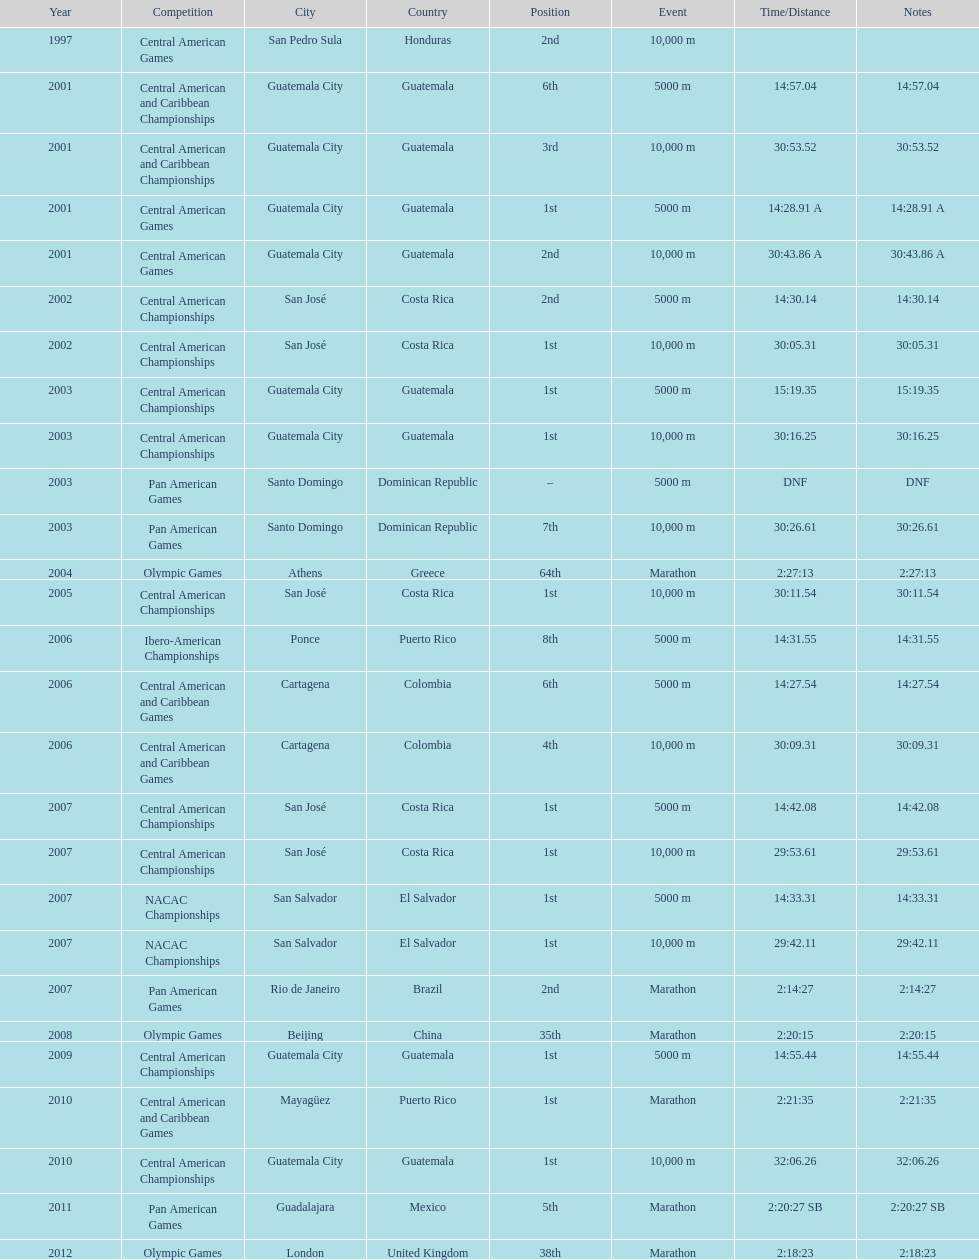What was the last competition in which a position of "2nd" was achieved? Pan American Games. Would you be able to parse every entry in this table? {'header': ['Year', 'Competition', 'City', 'Country', 'Position', 'Event', 'Time/Distance', 'Notes'], 'rows': [['1997', 'Central American Games', 'San Pedro Sula', 'Honduras', '2nd', '10,000 m', '', ''], ['2001', 'Central American and Caribbean Championships', 'Guatemala City', 'Guatemala', '6th', '5000 m', '14:57.04', '14:57.04'], ['2001', 'Central American and Caribbean Championships', 'Guatemala City', 'Guatemala', '3rd', '10,000 m', '30:53.52', '30:53.52'], ['2001', 'Central American Games', 'Guatemala City', 'Guatemala', '1st', '5000 m', '14:28.91 A', '14:28.91 A'], ['2001', 'Central American Games', 'Guatemala City', 'Guatemala', '2nd', '10,000 m', '30:43.86 A', '30:43.86 A'], ['2002', 'Central American Championships', 'San José', 'Costa Rica', '2nd', '5000 m', '14:30.14', '14:30.14'], ['2002', 'Central American Championships', 'San José', 'Costa Rica', '1st', '10,000 m', '30:05.31', '30:05.31'], ['2003', 'Central American Championships', 'Guatemala City', 'Guatemala', '1st', '5000 m', '15:19.35', '15:19.35'], ['2003', 'Central American Championships', 'Guatemala City', 'Guatemala', '1st', '10,000 m', '30:16.25', '30:16.25'], ['2003', 'Pan American Games', 'Santo Domingo', 'Dominican Republic', '–', '5000 m', 'DNF', 'DNF'], ['2003', 'Pan American Games', 'Santo Domingo', 'Dominican Republic', '7th', '10,000 m', '30:26.61', '30:26.61'], ['2004', 'Olympic Games', 'Athens', 'Greece', '64th', 'Marathon', '2:27:13', '2:27:13'], ['2005', 'Central American Championships', 'San José', 'Costa Rica', '1st', '10,000 m', '30:11.54', '30:11.54'], ['2006', 'Ibero-American Championships', 'Ponce', 'Puerto Rico', '8th', '5000 m', '14:31.55', '14:31.55'], ['2006', 'Central American and Caribbean Games', 'Cartagena', 'Colombia', '6th', '5000 m', '14:27.54', '14:27.54'], ['2006', 'Central American and Caribbean Games', 'Cartagena', 'Colombia', '4th', '10,000 m', '30:09.31', '30:09.31'], ['2007', 'Central American Championships', 'San José', 'Costa Rica', '1st', '5000 m', '14:42.08', '14:42.08'], ['2007', 'Central American Championships', 'San José', 'Costa Rica', '1st', '10,000 m', '29:53.61', '29:53.61'], ['2007', 'NACAC Championships', 'San Salvador', 'El Salvador', '1st', '5000 m', '14:33.31', '14:33.31'], ['2007', 'NACAC Championships', 'San Salvador', 'El Salvador', '1st', '10,000 m', '29:42.11', '29:42.11'], ['2007', 'Pan American Games', 'Rio de Janeiro', 'Brazil', '2nd', 'Marathon', '2:14:27', '2:14:27'], ['2008', 'Olympic Games', 'Beijing', 'China', '35th', 'Marathon', '2:20:15', '2:20:15'], ['2009', 'Central American Championships', 'Guatemala City', 'Guatemala', '1st', '5000 m', '14:55.44', '14:55.44'], ['2010', 'Central American and Caribbean Games', 'Mayagüez', 'Puerto Rico', '1st', 'Marathon', '2:21:35', '2:21:35'], ['2010', 'Central American Championships', 'Guatemala City', 'Guatemala', '1st', '10,000 m', '32:06.26', '32:06.26'], ['2011', 'Pan American Games', 'Guadalajara', 'Mexico', '5th', 'Marathon', '2:20:27 SB', '2:20:27 SB'], ['2012', 'Olympic Games', 'London', 'United Kingdom', '38th', 'Marathon', '2:18:23', '2:18:23']]} 